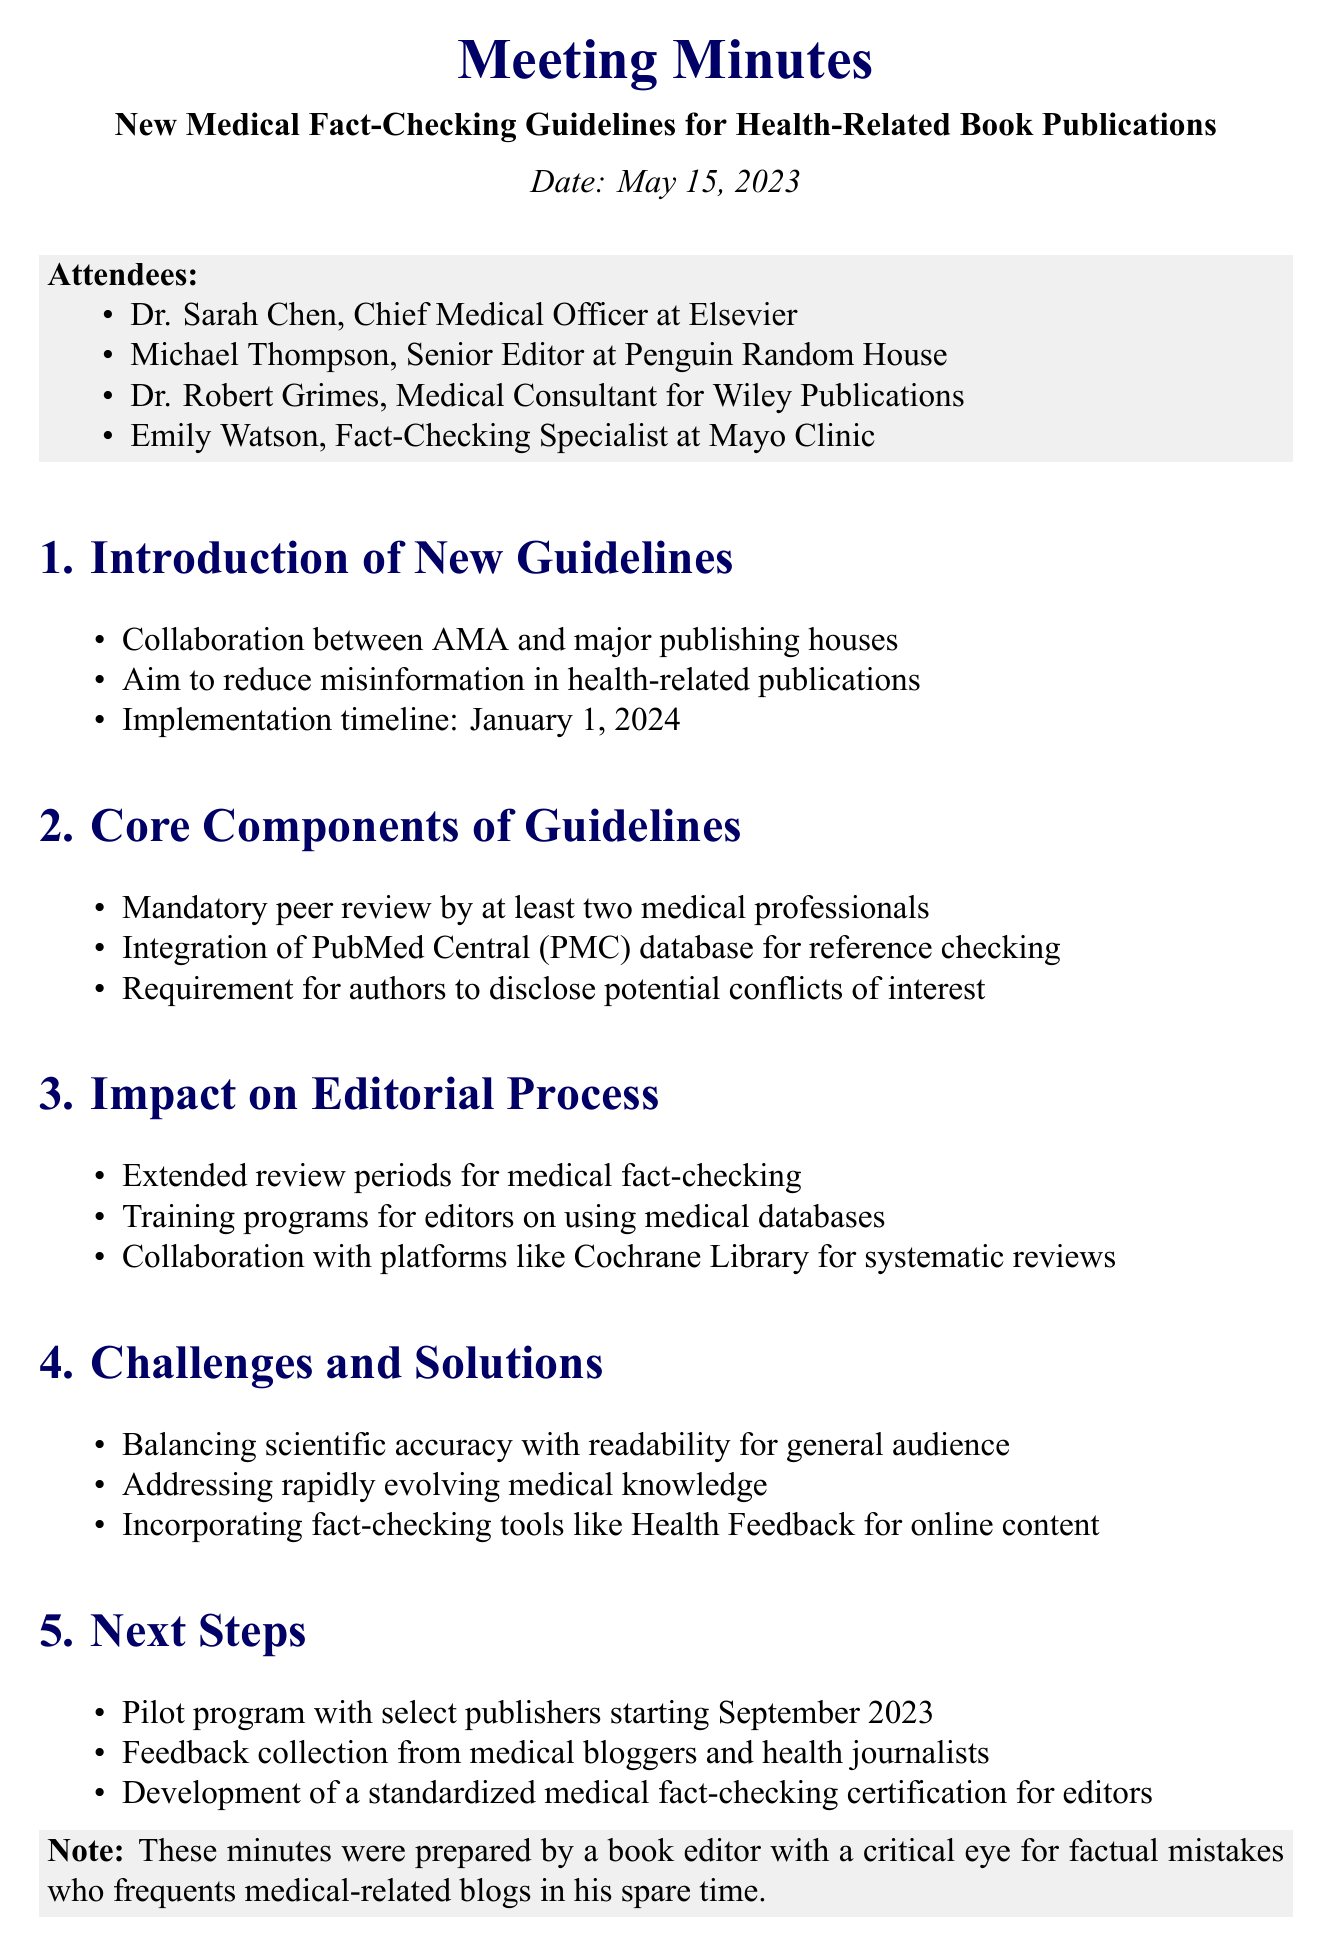What is the title of the meeting? The title of the meeting is the main subject discussed, which is "New Medical Fact-Checking Guidelines for Health-Related Book Publications."
Answer: New Medical Fact-Checking Guidelines for Health-Related Book Publications Who is the Chief Medical Officer at Elsevier? The document identifies Dr. Sarah Chen as the Chief Medical Officer at Elsevier.
Answer: Dr. Sarah Chen What is the implementation timeline for the new guidelines? The implementation timeline is the date when the guidelines will start to be enforced, which is stated as January 1, 2024.
Answer: January 1, 2024 How many medical professionals are required for peer review? The guidelines specify that at least two medical professionals are required for the mandatory peer review.
Answer: two What are the challenges mentioned in the meeting? The document lists several challenges, including balancing scientific accuracy with readability and addressing rapidly evolving medical knowledge.
Answer: Balancing scientific accuracy with readability What is one of the next steps mentioned in the meeting? The meeting outlines several next steps, one of which is a pilot program with select publishers starting in September 2023.
Answer: Pilot program with select publishers starting September 2023 Which database is integrated for reference checking? The guidelines detail the integration of the PubMed Central database for reference checking, making it a critical resource for authors.
Answer: PubMed Central (PMC) Who is the Fact-Checking Specialist at Mayo Clinic? Emily Watson is identified as the Fact-Checking Specialist at Mayo Clinic among the attendees.
Answer: Emily Watson 